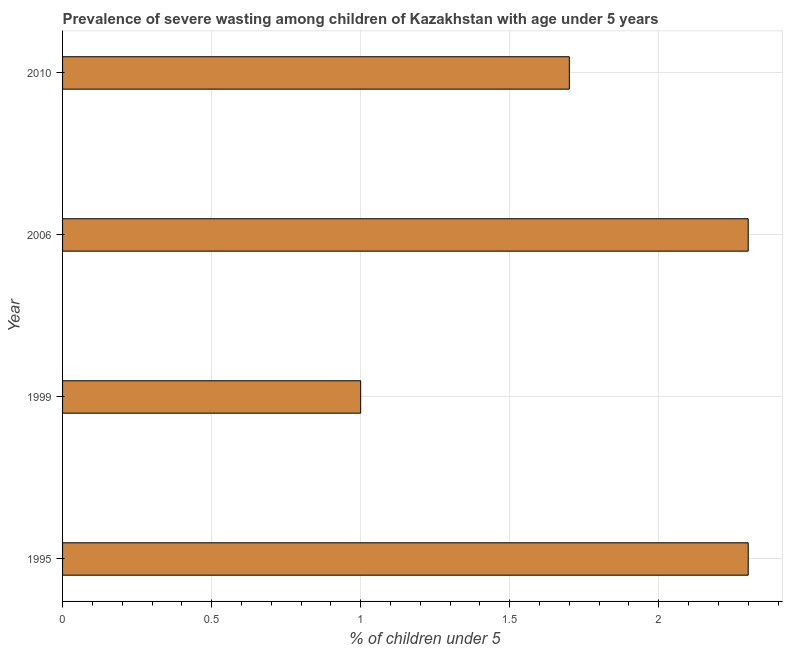Does the graph contain any zero values?
Your response must be concise. No. What is the title of the graph?
Your answer should be very brief. Prevalence of severe wasting among children of Kazakhstan with age under 5 years. What is the label or title of the X-axis?
Give a very brief answer.  % of children under 5. What is the prevalence of severe wasting in 2006?
Your answer should be compact. 2.3. Across all years, what is the maximum prevalence of severe wasting?
Keep it short and to the point. 2.3. Across all years, what is the minimum prevalence of severe wasting?
Ensure brevity in your answer.  1. In which year was the prevalence of severe wasting maximum?
Provide a succinct answer. 1995. In which year was the prevalence of severe wasting minimum?
Ensure brevity in your answer.  1999. What is the sum of the prevalence of severe wasting?
Make the answer very short. 7.3. What is the difference between the prevalence of severe wasting in 1999 and 2006?
Your answer should be compact. -1.3. What is the average prevalence of severe wasting per year?
Your answer should be very brief. 1.82. What is the median prevalence of severe wasting?
Provide a succinct answer. 2. What is the ratio of the prevalence of severe wasting in 2006 to that in 2010?
Give a very brief answer. 1.35. Is the difference between the prevalence of severe wasting in 1999 and 2010 greater than the difference between any two years?
Your answer should be very brief. No. Is the sum of the prevalence of severe wasting in 1995 and 2010 greater than the maximum prevalence of severe wasting across all years?
Provide a short and direct response. Yes. What is the difference between the highest and the lowest prevalence of severe wasting?
Keep it short and to the point. 1.3. In how many years, is the prevalence of severe wasting greater than the average prevalence of severe wasting taken over all years?
Give a very brief answer. 2. Are all the bars in the graph horizontal?
Make the answer very short. Yes. What is the difference between two consecutive major ticks on the X-axis?
Offer a very short reply. 0.5. Are the values on the major ticks of X-axis written in scientific E-notation?
Your response must be concise. No. What is the  % of children under 5 in 1995?
Provide a succinct answer. 2.3. What is the  % of children under 5 in 1999?
Make the answer very short. 1. What is the  % of children under 5 of 2006?
Your response must be concise. 2.3. What is the  % of children under 5 in 2010?
Offer a terse response. 1.7. What is the difference between the  % of children under 5 in 1995 and 2006?
Make the answer very short. 0. What is the difference between the  % of children under 5 in 1999 and 2006?
Ensure brevity in your answer.  -1.3. What is the difference between the  % of children under 5 in 2006 and 2010?
Your answer should be compact. 0.6. What is the ratio of the  % of children under 5 in 1995 to that in 1999?
Provide a succinct answer. 2.3. What is the ratio of the  % of children under 5 in 1995 to that in 2010?
Give a very brief answer. 1.35. What is the ratio of the  % of children under 5 in 1999 to that in 2006?
Your response must be concise. 0.43. What is the ratio of the  % of children under 5 in 1999 to that in 2010?
Keep it short and to the point. 0.59. What is the ratio of the  % of children under 5 in 2006 to that in 2010?
Make the answer very short. 1.35. 